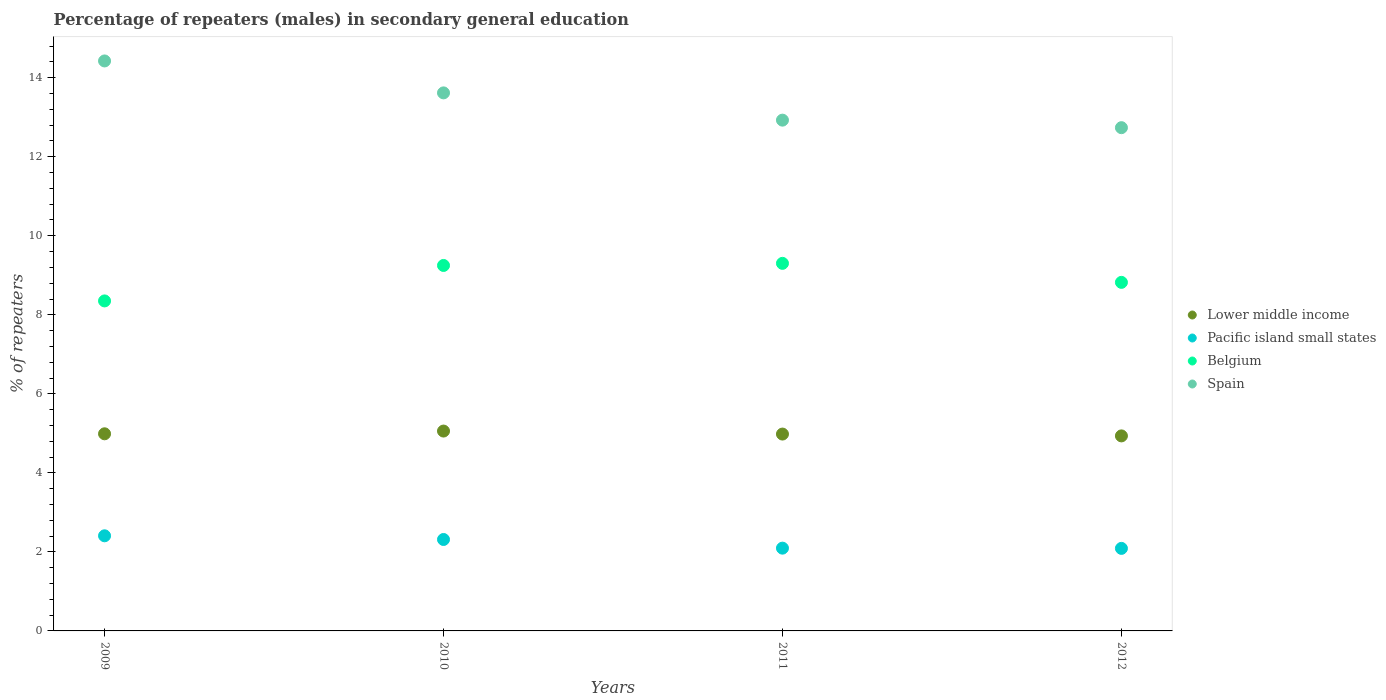How many different coloured dotlines are there?
Make the answer very short. 4. What is the percentage of male repeaters in Lower middle income in 2012?
Make the answer very short. 4.94. Across all years, what is the maximum percentage of male repeaters in Lower middle income?
Ensure brevity in your answer.  5.06. Across all years, what is the minimum percentage of male repeaters in Spain?
Offer a very short reply. 12.74. What is the total percentage of male repeaters in Spain in the graph?
Offer a very short reply. 53.7. What is the difference between the percentage of male repeaters in Lower middle income in 2009 and that in 2010?
Offer a terse response. -0.07. What is the difference between the percentage of male repeaters in Lower middle income in 2011 and the percentage of male repeaters in Belgium in 2012?
Provide a short and direct response. -3.84. What is the average percentage of male repeaters in Lower middle income per year?
Give a very brief answer. 4.99. In the year 2011, what is the difference between the percentage of male repeaters in Pacific island small states and percentage of male repeaters in Spain?
Provide a short and direct response. -10.83. In how many years, is the percentage of male repeaters in Spain greater than 3.2 %?
Keep it short and to the point. 4. What is the ratio of the percentage of male repeaters in Pacific island small states in 2010 to that in 2011?
Make the answer very short. 1.1. Is the difference between the percentage of male repeaters in Pacific island small states in 2009 and 2012 greater than the difference between the percentage of male repeaters in Spain in 2009 and 2012?
Your response must be concise. No. What is the difference between the highest and the second highest percentage of male repeaters in Pacific island small states?
Provide a succinct answer. 0.09. What is the difference between the highest and the lowest percentage of male repeaters in Spain?
Offer a terse response. 1.69. Is the sum of the percentage of male repeaters in Pacific island small states in 2009 and 2010 greater than the maximum percentage of male repeaters in Belgium across all years?
Your answer should be compact. No. Is the percentage of male repeaters in Spain strictly greater than the percentage of male repeaters in Lower middle income over the years?
Keep it short and to the point. Yes. Is the percentage of male repeaters in Belgium strictly less than the percentage of male repeaters in Spain over the years?
Make the answer very short. Yes. How many dotlines are there?
Give a very brief answer. 4. What is the difference between two consecutive major ticks on the Y-axis?
Offer a very short reply. 2. Are the values on the major ticks of Y-axis written in scientific E-notation?
Your answer should be compact. No. Does the graph contain any zero values?
Your response must be concise. No. Does the graph contain grids?
Provide a short and direct response. No. Where does the legend appear in the graph?
Your answer should be very brief. Center right. How many legend labels are there?
Provide a succinct answer. 4. What is the title of the graph?
Offer a terse response. Percentage of repeaters (males) in secondary general education. Does "Guatemala" appear as one of the legend labels in the graph?
Your response must be concise. No. What is the label or title of the X-axis?
Offer a very short reply. Years. What is the label or title of the Y-axis?
Give a very brief answer. % of repeaters. What is the % of repeaters of Lower middle income in 2009?
Make the answer very short. 4.99. What is the % of repeaters of Pacific island small states in 2009?
Give a very brief answer. 2.41. What is the % of repeaters of Belgium in 2009?
Ensure brevity in your answer.  8.35. What is the % of repeaters of Spain in 2009?
Give a very brief answer. 14.42. What is the % of repeaters of Lower middle income in 2010?
Keep it short and to the point. 5.06. What is the % of repeaters of Pacific island small states in 2010?
Ensure brevity in your answer.  2.31. What is the % of repeaters of Belgium in 2010?
Offer a very short reply. 9.25. What is the % of repeaters of Spain in 2010?
Provide a short and direct response. 13.62. What is the % of repeaters of Lower middle income in 2011?
Your answer should be very brief. 4.98. What is the % of repeaters of Pacific island small states in 2011?
Make the answer very short. 2.09. What is the % of repeaters of Belgium in 2011?
Offer a terse response. 9.3. What is the % of repeaters in Spain in 2011?
Your response must be concise. 12.93. What is the % of repeaters in Lower middle income in 2012?
Your answer should be compact. 4.94. What is the % of repeaters in Pacific island small states in 2012?
Your answer should be compact. 2.09. What is the % of repeaters of Belgium in 2012?
Offer a terse response. 8.82. What is the % of repeaters in Spain in 2012?
Keep it short and to the point. 12.74. Across all years, what is the maximum % of repeaters in Lower middle income?
Your answer should be compact. 5.06. Across all years, what is the maximum % of repeaters of Pacific island small states?
Your response must be concise. 2.41. Across all years, what is the maximum % of repeaters in Belgium?
Offer a terse response. 9.3. Across all years, what is the maximum % of repeaters in Spain?
Offer a very short reply. 14.42. Across all years, what is the minimum % of repeaters in Lower middle income?
Offer a very short reply. 4.94. Across all years, what is the minimum % of repeaters in Pacific island small states?
Provide a short and direct response. 2.09. Across all years, what is the minimum % of repeaters in Belgium?
Offer a terse response. 8.35. Across all years, what is the minimum % of repeaters in Spain?
Keep it short and to the point. 12.74. What is the total % of repeaters of Lower middle income in the graph?
Give a very brief answer. 19.96. What is the total % of repeaters of Pacific island small states in the graph?
Your answer should be very brief. 8.9. What is the total % of repeaters of Belgium in the graph?
Make the answer very short. 35.72. What is the total % of repeaters of Spain in the graph?
Offer a very short reply. 53.7. What is the difference between the % of repeaters of Lower middle income in 2009 and that in 2010?
Ensure brevity in your answer.  -0.07. What is the difference between the % of repeaters in Pacific island small states in 2009 and that in 2010?
Your answer should be very brief. 0.09. What is the difference between the % of repeaters in Belgium in 2009 and that in 2010?
Ensure brevity in your answer.  -0.9. What is the difference between the % of repeaters of Spain in 2009 and that in 2010?
Your answer should be very brief. 0.81. What is the difference between the % of repeaters in Lower middle income in 2009 and that in 2011?
Offer a terse response. 0.01. What is the difference between the % of repeaters of Pacific island small states in 2009 and that in 2011?
Your answer should be compact. 0.31. What is the difference between the % of repeaters in Belgium in 2009 and that in 2011?
Give a very brief answer. -0.95. What is the difference between the % of repeaters of Spain in 2009 and that in 2011?
Make the answer very short. 1.5. What is the difference between the % of repeaters in Lower middle income in 2009 and that in 2012?
Offer a terse response. 0.05. What is the difference between the % of repeaters in Pacific island small states in 2009 and that in 2012?
Ensure brevity in your answer.  0.32. What is the difference between the % of repeaters of Belgium in 2009 and that in 2012?
Ensure brevity in your answer.  -0.47. What is the difference between the % of repeaters of Spain in 2009 and that in 2012?
Your response must be concise. 1.69. What is the difference between the % of repeaters of Lower middle income in 2010 and that in 2011?
Provide a short and direct response. 0.08. What is the difference between the % of repeaters in Pacific island small states in 2010 and that in 2011?
Provide a succinct answer. 0.22. What is the difference between the % of repeaters of Belgium in 2010 and that in 2011?
Your response must be concise. -0.05. What is the difference between the % of repeaters of Spain in 2010 and that in 2011?
Keep it short and to the point. 0.69. What is the difference between the % of repeaters of Lower middle income in 2010 and that in 2012?
Give a very brief answer. 0.12. What is the difference between the % of repeaters in Pacific island small states in 2010 and that in 2012?
Your answer should be compact. 0.23. What is the difference between the % of repeaters of Belgium in 2010 and that in 2012?
Provide a succinct answer. 0.43. What is the difference between the % of repeaters of Spain in 2010 and that in 2012?
Provide a short and direct response. 0.88. What is the difference between the % of repeaters in Lower middle income in 2011 and that in 2012?
Ensure brevity in your answer.  0.05. What is the difference between the % of repeaters of Pacific island small states in 2011 and that in 2012?
Give a very brief answer. 0.01. What is the difference between the % of repeaters in Belgium in 2011 and that in 2012?
Your response must be concise. 0.48. What is the difference between the % of repeaters of Spain in 2011 and that in 2012?
Give a very brief answer. 0.19. What is the difference between the % of repeaters of Lower middle income in 2009 and the % of repeaters of Pacific island small states in 2010?
Offer a very short reply. 2.67. What is the difference between the % of repeaters of Lower middle income in 2009 and the % of repeaters of Belgium in 2010?
Keep it short and to the point. -4.26. What is the difference between the % of repeaters of Lower middle income in 2009 and the % of repeaters of Spain in 2010?
Your answer should be very brief. -8.63. What is the difference between the % of repeaters in Pacific island small states in 2009 and the % of repeaters in Belgium in 2010?
Make the answer very short. -6.84. What is the difference between the % of repeaters of Pacific island small states in 2009 and the % of repeaters of Spain in 2010?
Your answer should be very brief. -11.21. What is the difference between the % of repeaters of Belgium in 2009 and the % of repeaters of Spain in 2010?
Provide a short and direct response. -5.26. What is the difference between the % of repeaters of Lower middle income in 2009 and the % of repeaters of Pacific island small states in 2011?
Your response must be concise. 2.89. What is the difference between the % of repeaters in Lower middle income in 2009 and the % of repeaters in Belgium in 2011?
Offer a very short reply. -4.31. What is the difference between the % of repeaters in Lower middle income in 2009 and the % of repeaters in Spain in 2011?
Give a very brief answer. -7.94. What is the difference between the % of repeaters in Pacific island small states in 2009 and the % of repeaters in Belgium in 2011?
Ensure brevity in your answer.  -6.89. What is the difference between the % of repeaters of Pacific island small states in 2009 and the % of repeaters of Spain in 2011?
Ensure brevity in your answer.  -10.52. What is the difference between the % of repeaters of Belgium in 2009 and the % of repeaters of Spain in 2011?
Ensure brevity in your answer.  -4.58. What is the difference between the % of repeaters of Lower middle income in 2009 and the % of repeaters of Pacific island small states in 2012?
Your answer should be compact. 2.9. What is the difference between the % of repeaters of Lower middle income in 2009 and the % of repeaters of Belgium in 2012?
Keep it short and to the point. -3.83. What is the difference between the % of repeaters in Lower middle income in 2009 and the % of repeaters in Spain in 2012?
Ensure brevity in your answer.  -7.75. What is the difference between the % of repeaters in Pacific island small states in 2009 and the % of repeaters in Belgium in 2012?
Give a very brief answer. -6.41. What is the difference between the % of repeaters of Pacific island small states in 2009 and the % of repeaters of Spain in 2012?
Ensure brevity in your answer.  -10.33. What is the difference between the % of repeaters in Belgium in 2009 and the % of repeaters in Spain in 2012?
Your answer should be very brief. -4.38. What is the difference between the % of repeaters in Lower middle income in 2010 and the % of repeaters in Pacific island small states in 2011?
Your answer should be very brief. 2.96. What is the difference between the % of repeaters of Lower middle income in 2010 and the % of repeaters of Belgium in 2011?
Offer a very short reply. -4.24. What is the difference between the % of repeaters of Lower middle income in 2010 and the % of repeaters of Spain in 2011?
Keep it short and to the point. -7.87. What is the difference between the % of repeaters in Pacific island small states in 2010 and the % of repeaters in Belgium in 2011?
Provide a short and direct response. -6.99. What is the difference between the % of repeaters of Pacific island small states in 2010 and the % of repeaters of Spain in 2011?
Offer a very short reply. -10.61. What is the difference between the % of repeaters of Belgium in 2010 and the % of repeaters of Spain in 2011?
Keep it short and to the point. -3.68. What is the difference between the % of repeaters of Lower middle income in 2010 and the % of repeaters of Pacific island small states in 2012?
Keep it short and to the point. 2.97. What is the difference between the % of repeaters in Lower middle income in 2010 and the % of repeaters in Belgium in 2012?
Provide a short and direct response. -3.76. What is the difference between the % of repeaters in Lower middle income in 2010 and the % of repeaters in Spain in 2012?
Offer a very short reply. -7.68. What is the difference between the % of repeaters in Pacific island small states in 2010 and the % of repeaters in Belgium in 2012?
Give a very brief answer. -6.51. What is the difference between the % of repeaters of Pacific island small states in 2010 and the % of repeaters of Spain in 2012?
Ensure brevity in your answer.  -10.42. What is the difference between the % of repeaters of Belgium in 2010 and the % of repeaters of Spain in 2012?
Your answer should be very brief. -3.49. What is the difference between the % of repeaters in Lower middle income in 2011 and the % of repeaters in Pacific island small states in 2012?
Provide a succinct answer. 2.89. What is the difference between the % of repeaters of Lower middle income in 2011 and the % of repeaters of Belgium in 2012?
Give a very brief answer. -3.84. What is the difference between the % of repeaters in Lower middle income in 2011 and the % of repeaters in Spain in 2012?
Offer a very short reply. -7.75. What is the difference between the % of repeaters of Pacific island small states in 2011 and the % of repeaters of Belgium in 2012?
Ensure brevity in your answer.  -6.73. What is the difference between the % of repeaters in Pacific island small states in 2011 and the % of repeaters in Spain in 2012?
Provide a succinct answer. -10.64. What is the difference between the % of repeaters of Belgium in 2011 and the % of repeaters of Spain in 2012?
Ensure brevity in your answer.  -3.43. What is the average % of repeaters in Lower middle income per year?
Your response must be concise. 4.99. What is the average % of repeaters in Pacific island small states per year?
Ensure brevity in your answer.  2.23. What is the average % of repeaters in Belgium per year?
Make the answer very short. 8.93. What is the average % of repeaters in Spain per year?
Offer a very short reply. 13.43. In the year 2009, what is the difference between the % of repeaters of Lower middle income and % of repeaters of Pacific island small states?
Your answer should be compact. 2.58. In the year 2009, what is the difference between the % of repeaters in Lower middle income and % of repeaters in Belgium?
Your answer should be compact. -3.36. In the year 2009, what is the difference between the % of repeaters in Lower middle income and % of repeaters in Spain?
Provide a succinct answer. -9.44. In the year 2009, what is the difference between the % of repeaters of Pacific island small states and % of repeaters of Belgium?
Your answer should be compact. -5.94. In the year 2009, what is the difference between the % of repeaters in Pacific island small states and % of repeaters in Spain?
Ensure brevity in your answer.  -12.02. In the year 2009, what is the difference between the % of repeaters of Belgium and % of repeaters of Spain?
Keep it short and to the point. -6.07. In the year 2010, what is the difference between the % of repeaters in Lower middle income and % of repeaters in Pacific island small states?
Give a very brief answer. 2.74. In the year 2010, what is the difference between the % of repeaters in Lower middle income and % of repeaters in Belgium?
Keep it short and to the point. -4.19. In the year 2010, what is the difference between the % of repeaters in Lower middle income and % of repeaters in Spain?
Offer a terse response. -8.56. In the year 2010, what is the difference between the % of repeaters of Pacific island small states and % of repeaters of Belgium?
Your answer should be compact. -6.93. In the year 2010, what is the difference between the % of repeaters of Pacific island small states and % of repeaters of Spain?
Your response must be concise. -11.3. In the year 2010, what is the difference between the % of repeaters of Belgium and % of repeaters of Spain?
Provide a succinct answer. -4.37. In the year 2011, what is the difference between the % of repeaters in Lower middle income and % of repeaters in Pacific island small states?
Your answer should be very brief. 2.89. In the year 2011, what is the difference between the % of repeaters in Lower middle income and % of repeaters in Belgium?
Keep it short and to the point. -4.32. In the year 2011, what is the difference between the % of repeaters in Lower middle income and % of repeaters in Spain?
Your response must be concise. -7.94. In the year 2011, what is the difference between the % of repeaters of Pacific island small states and % of repeaters of Belgium?
Your answer should be very brief. -7.21. In the year 2011, what is the difference between the % of repeaters of Pacific island small states and % of repeaters of Spain?
Make the answer very short. -10.83. In the year 2011, what is the difference between the % of repeaters of Belgium and % of repeaters of Spain?
Ensure brevity in your answer.  -3.62. In the year 2012, what is the difference between the % of repeaters in Lower middle income and % of repeaters in Pacific island small states?
Your answer should be compact. 2.85. In the year 2012, what is the difference between the % of repeaters in Lower middle income and % of repeaters in Belgium?
Give a very brief answer. -3.89. In the year 2012, what is the difference between the % of repeaters of Lower middle income and % of repeaters of Spain?
Your answer should be very brief. -7.8. In the year 2012, what is the difference between the % of repeaters in Pacific island small states and % of repeaters in Belgium?
Provide a succinct answer. -6.73. In the year 2012, what is the difference between the % of repeaters in Pacific island small states and % of repeaters in Spain?
Offer a terse response. -10.65. In the year 2012, what is the difference between the % of repeaters of Belgium and % of repeaters of Spain?
Keep it short and to the point. -3.91. What is the ratio of the % of repeaters in Lower middle income in 2009 to that in 2010?
Offer a very short reply. 0.99. What is the ratio of the % of repeaters of Pacific island small states in 2009 to that in 2010?
Offer a very short reply. 1.04. What is the ratio of the % of repeaters in Belgium in 2009 to that in 2010?
Provide a succinct answer. 0.9. What is the ratio of the % of repeaters of Spain in 2009 to that in 2010?
Provide a succinct answer. 1.06. What is the ratio of the % of repeaters of Pacific island small states in 2009 to that in 2011?
Give a very brief answer. 1.15. What is the ratio of the % of repeaters in Belgium in 2009 to that in 2011?
Keep it short and to the point. 0.9. What is the ratio of the % of repeaters in Spain in 2009 to that in 2011?
Offer a terse response. 1.12. What is the ratio of the % of repeaters in Lower middle income in 2009 to that in 2012?
Offer a terse response. 1.01. What is the ratio of the % of repeaters in Pacific island small states in 2009 to that in 2012?
Provide a succinct answer. 1.15. What is the ratio of the % of repeaters of Belgium in 2009 to that in 2012?
Keep it short and to the point. 0.95. What is the ratio of the % of repeaters in Spain in 2009 to that in 2012?
Your answer should be compact. 1.13. What is the ratio of the % of repeaters in Lower middle income in 2010 to that in 2011?
Provide a short and direct response. 1.02. What is the ratio of the % of repeaters in Pacific island small states in 2010 to that in 2011?
Provide a short and direct response. 1.1. What is the ratio of the % of repeaters of Spain in 2010 to that in 2011?
Offer a very short reply. 1.05. What is the ratio of the % of repeaters of Lower middle income in 2010 to that in 2012?
Keep it short and to the point. 1.02. What is the ratio of the % of repeaters of Pacific island small states in 2010 to that in 2012?
Keep it short and to the point. 1.11. What is the ratio of the % of repeaters in Belgium in 2010 to that in 2012?
Your response must be concise. 1.05. What is the ratio of the % of repeaters of Spain in 2010 to that in 2012?
Your answer should be compact. 1.07. What is the ratio of the % of repeaters of Lower middle income in 2011 to that in 2012?
Provide a succinct answer. 1.01. What is the ratio of the % of repeaters of Pacific island small states in 2011 to that in 2012?
Offer a very short reply. 1. What is the ratio of the % of repeaters of Belgium in 2011 to that in 2012?
Your answer should be compact. 1.05. What is the ratio of the % of repeaters of Spain in 2011 to that in 2012?
Offer a terse response. 1.01. What is the difference between the highest and the second highest % of repeaters in Lower middle income?
Keep it short and to the point. 0.07. What is the difference between the highest and the second highest % of repeaters in Pacific island small states?
Ensure brevity in your answer.  0.09. What is the difference between the highest and the second highest % of repeaters of Belgium?
Make the answer very short. 0.05. What is the difference between the highest and the second highest % of repeaters in Spain?
Give a very brief answer. 0.81. What is the difference between the highest and the lowest % of repeaters in Lower middle income?
Your answer should be very brief. 0.12. What is the difference between the highest and the lowest % of repeaters in Pacific island small states?
Offer a terse response. 0.32. What is the difference between the highest and the lowest % of repeaters in Belgium?
Give a very brief answer. 0.95. What is the difference between the highest and the lowest % of repeaters of Spain?
Your answer should be very brief. 1.69. 